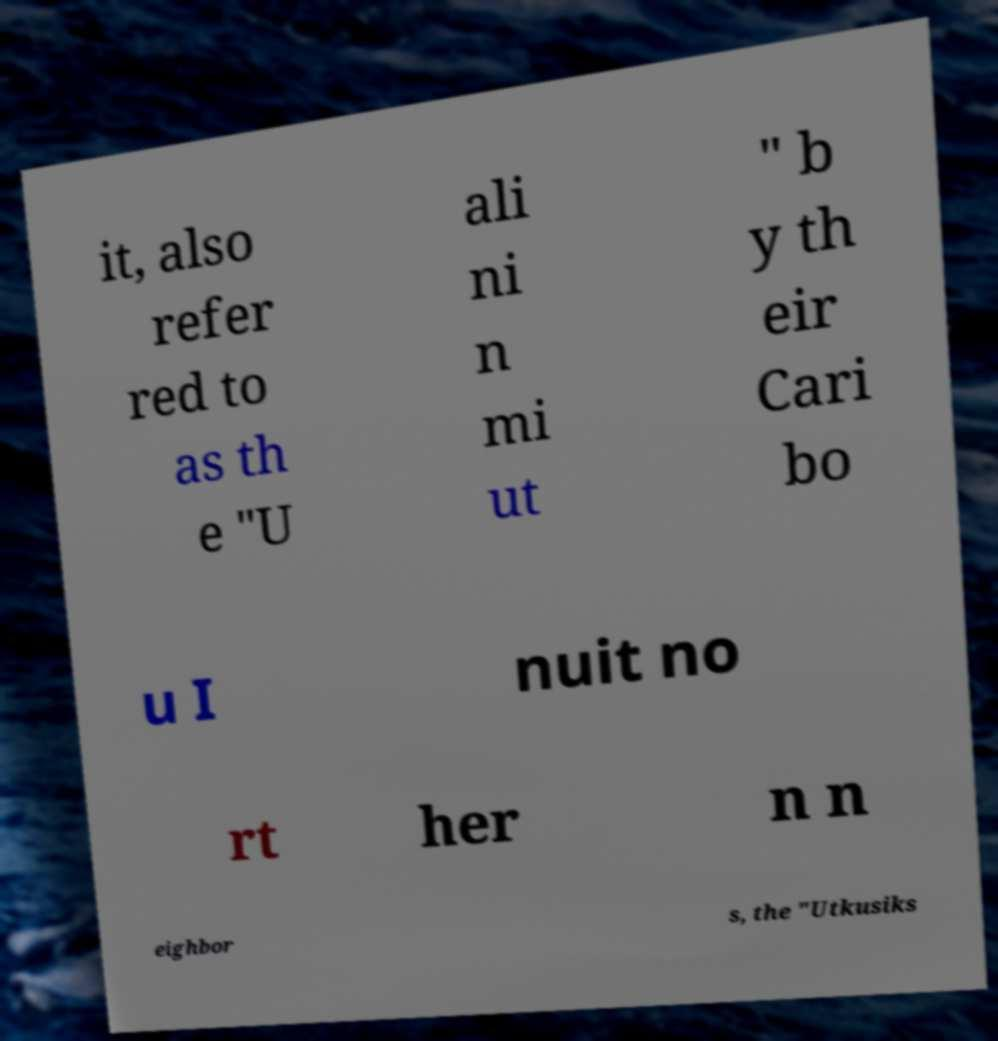For documentation purposes, I need the text within this image transcribed. Could you provide that? it, also refer red to as th e "U ali ni n mi ut " b y th eir Cari bo u I nuit no rt her n n eighbor s, the "Utkusiks 